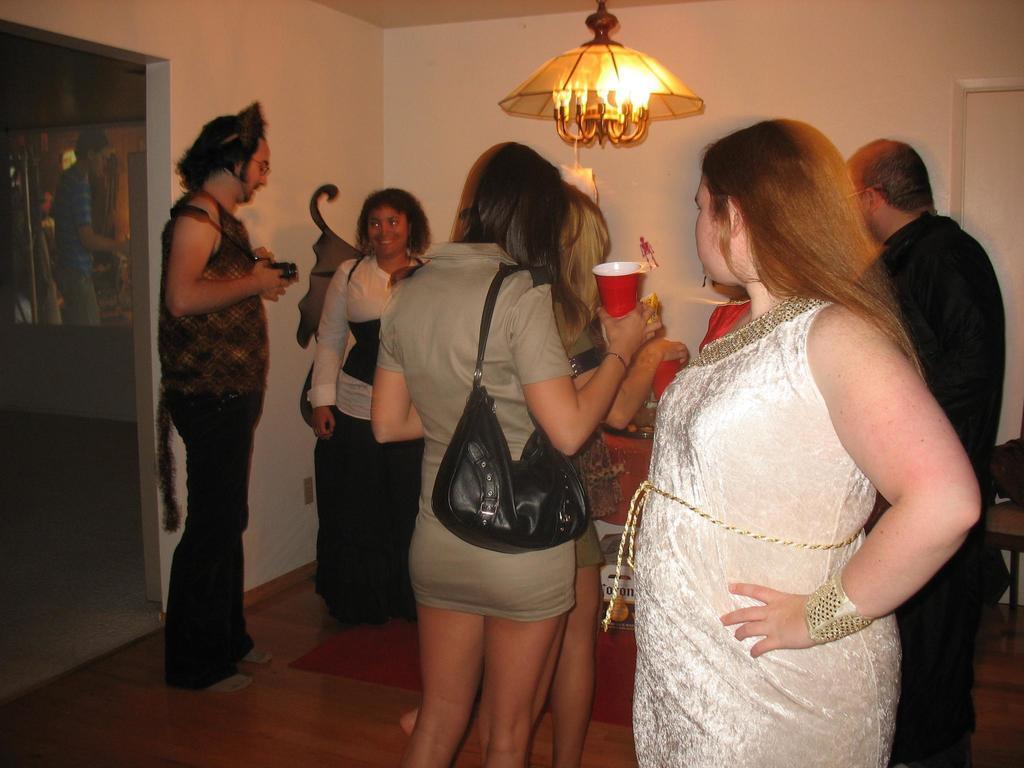Describe this image in one or two sentences. This is the picture of a place where we have some people holding some glasses, among them a lady is wearing the bag and also we can see a lamp to the roof. 